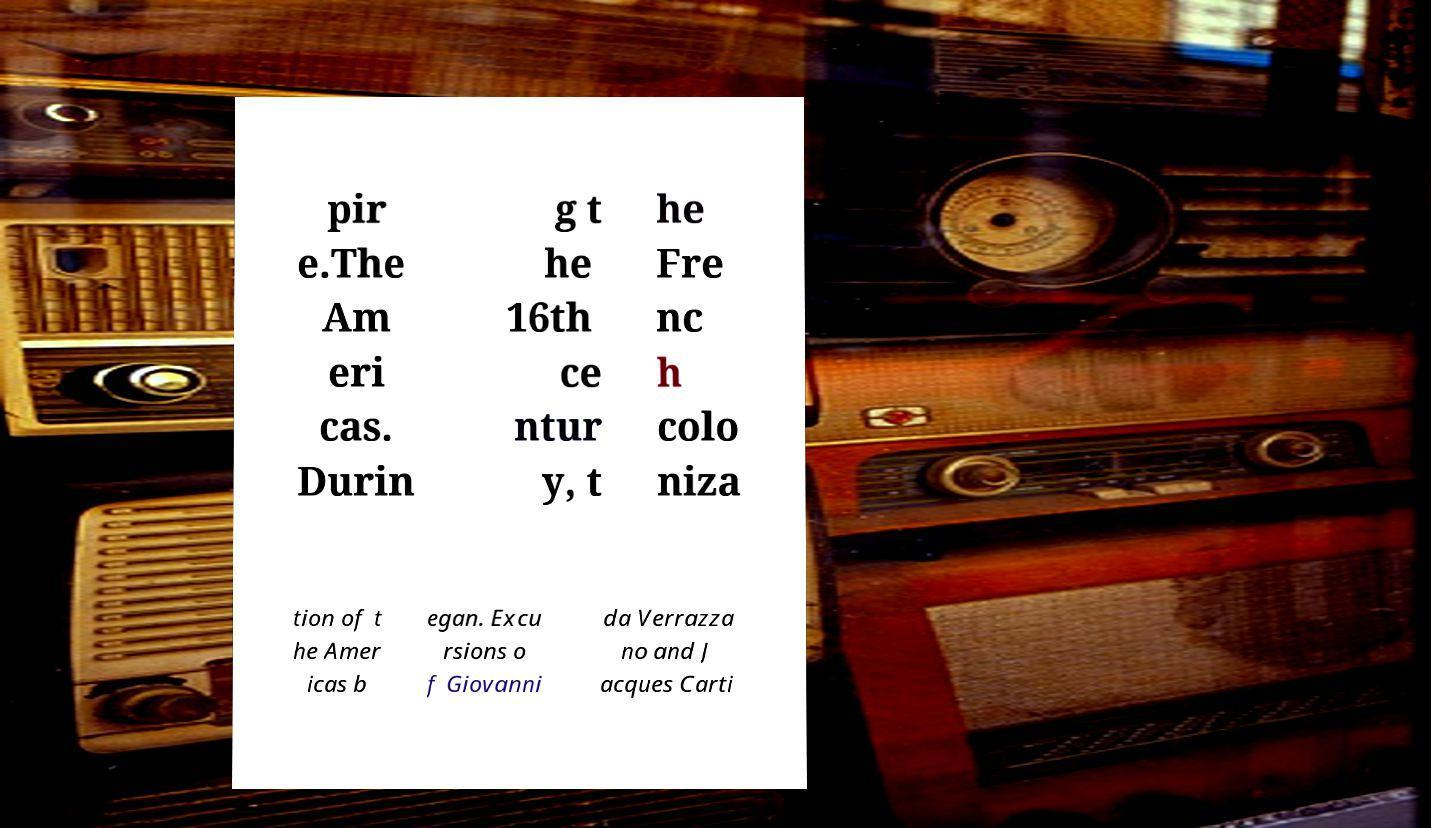For documentation purposes, I need the text within this image transcribed. Could you provide that? pir e.The Am eri cas. Durin g t he 16th ce ntur y, t he Fre nc h colo niza tion of t he Amer icas b egan. Excu rsions o f Giovanni da Verrazza no and J acques Carti 